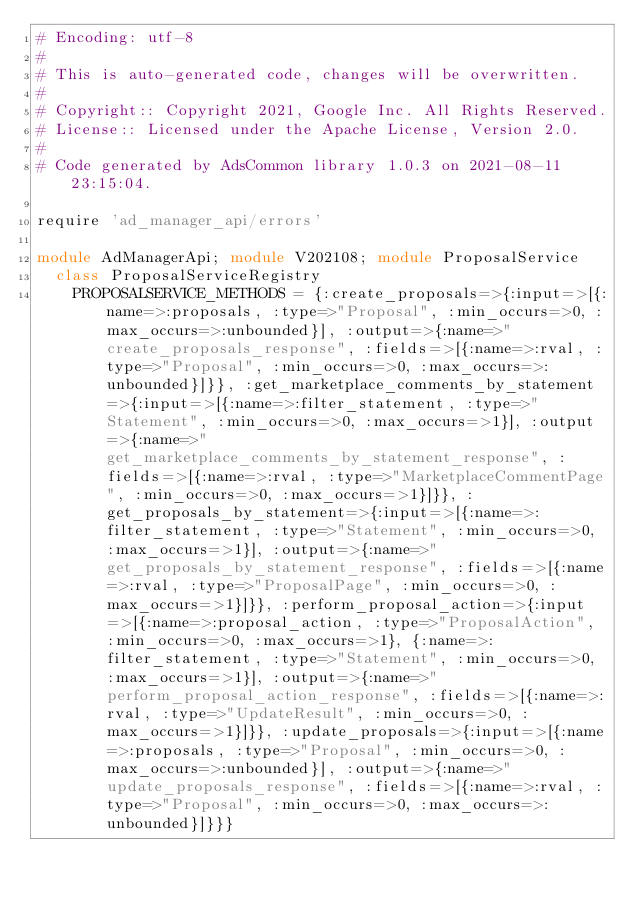Convert code to text. <code><loc_0><loc_0><loc_500><loc_500><_Ruby_># Encoding: utf-8
#
# This is auto-generated code, changes will be overwritten.
#
# Copyright:: Copyright 2021, Google Inc. All Rights Reserved.
# License:: Licensed under the Apache License, Version 2.0.
#
# Code generated by AdsCommon library 1.0.3 on 2021-08-11 23:15:04.

require 'ad_manager_api/errors'

module AdManagerApi; module V202108; module ProposalService
  class ProposalServiceRegistry
    PROPOSALSERVICE_METHODS = {:create_proposals=>{:input=>[{:name=>:proposals, :type=>"Proposal", :min_occurs=>0, :max_occurs=>:unbounded}], :output=>{:name=>"create_proposals_response", :fields=>[{:name=>:rval, :type=>"Proposal", :min_occurs=>0, :max_occurs=>:unbounded}]}}, :get_marketplace_comments_by_statement=>{:input=>[{:name=>:filter_statement, :type=>"Statement", :min_occurs=>0, :max_occurs=>1}], :output=>{:name=>"get_marketplace_comments_by_statement_response", :fields=>[{:name=>:rval, :type=>"MarketplaceCommentPage", :min_occurs=>0, :max_occurs=>1}]}}, :get_proposals_by_statement=>{:input=>[{:name=>:filter_statement, :type=>"Statement", :min_occurs=>0, :max_occurs=>1}], :output=>{:name=>"get_proposals_by_statement_response", :fields=>[{:name=>:rval, :type=>"ProposalPage", :min_occurs=>0, :max_occurs=>1}]}}, :perform_proposal_action=>{:input=>[{:name=>:proposal_action, :type=>"ProposalAction", :min_occurs=>0, :max_occurs=>1}, {:name=>:filter_statement, :type=>"Statement", :min_occurs=>0, :max_occurs=>1}], :output=>{:name=>"perform_proposal_action_response", :fields=>[{:name=>:rval, :type=>"UpdateResult", :min_occurs=>0, :max_occurs=>1}]}}, :update_proposals=>{:input=>[{:name=>:proposals, :type=>"Proposal", :min_occurs=>0, :max_occurs=>:unbounded}], :output=>{:name=>"update_proposals_response", :fields=>[{:name=>:rval, :type=>"Proposal", :min_occurs=>0, :max_occurs=>:unbounded}]}}}</code> 